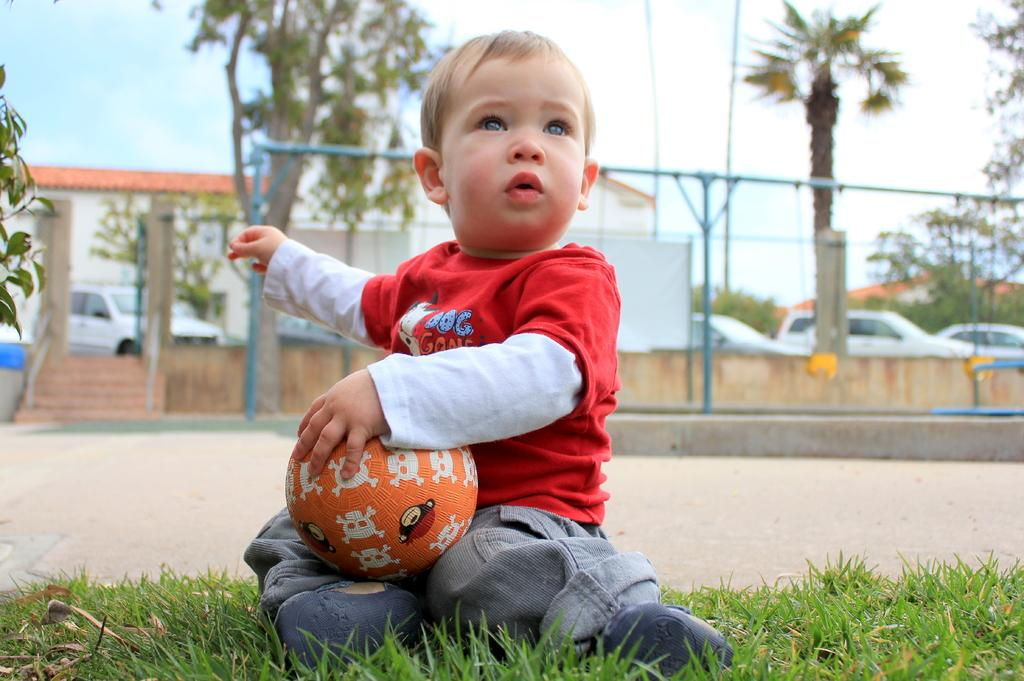What is the main subject of the image? The main subject of the image is a kid. Where is the kid located in the image? The kid is sitting on the grass in the lawn. What is the kid holding in his hands? The kid is holding a ball in his hands. What can be seen in the background of the image? There is a fence, a cat, trees, and the sky visible in the background of the image. What is the condition of the sky in the image? The sky is visible in the background of the image, and there are clouds present. What type of dinner is being served in the image? There is no dinner present in the image; it features a kid sitting on the grass holding a ball. Is there any sleet visible in the image? There is no sleet present in the image; the sky has clouds, but no precipitation is mentioned or visible. 